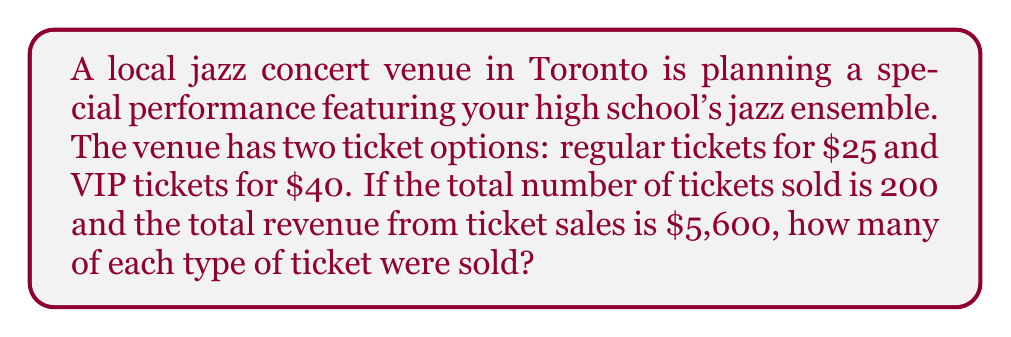Help me with this question. Let's approach this problem using a system of equations. We'll define our variables as:

$x$ = number of regular tickets sold
$y$ = number of VIP tickets sold

From the information given, we can set up two equations:

1. Total number of tickets equation:
   $x + y = 200$

2. Total revenue equation:
   $25x + 40y = 5600$

Now, let's solve this system of equations:

1. From the first equation, we can express $x$ in terms of $y$:
   $x = 200 - y$

2. Substitute this into the second equation:
   $25(200 - y) + 40y = 5600$

3. Simplify:
   $5000 - 25y + 40y = 5600$
   $5000 + 15y = 5600$

4. Solve for $y$:
   $15y = 600$
   $y = 40$

5. Now that we know $y$, we can find $x$:
   $x = 200 - y = 200 - 40 = 160$

Therefore, 160 regular tickets and 40 VIP tickets were sold.

To verify:
- Total tickets: $160 + 40 = 200$ ✓
- Total revenue: $25(160) + 40(40) = 4000 + 1600 = 5600$ ✓
Answer: 160 regular tickets and 40 VIP tickets were sold. 